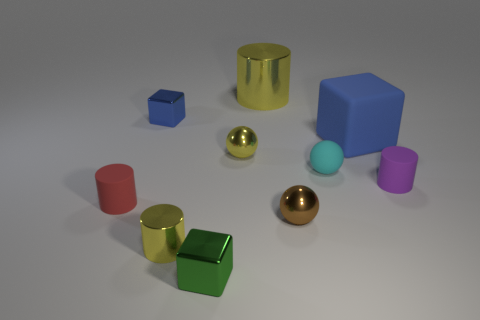Subtract 1 cylinders. How many cylinders are left? 3 Subtract all gray cylinders. Subtract all red blocks. How many cylinders are left? 4 Subtract all spheres. How many objects are left? 7 Add 8 tiny yellow cylinders. How many tiny yellow cylinders exist? 9 Subtract 0 gray balls. How many objects are left? 10 Subtract all big yellow shiny cylinders. Subtract all red matte cylinders. How many objects are left? 8 Add 6 tiny shiny balls. How many tiny shiny balls are left? 8 